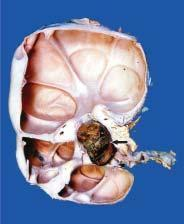re these cysts communicating with the pelvi-calyceal system unlike polycystic kidney?
Answer the question using a single word or phrase. Yes 